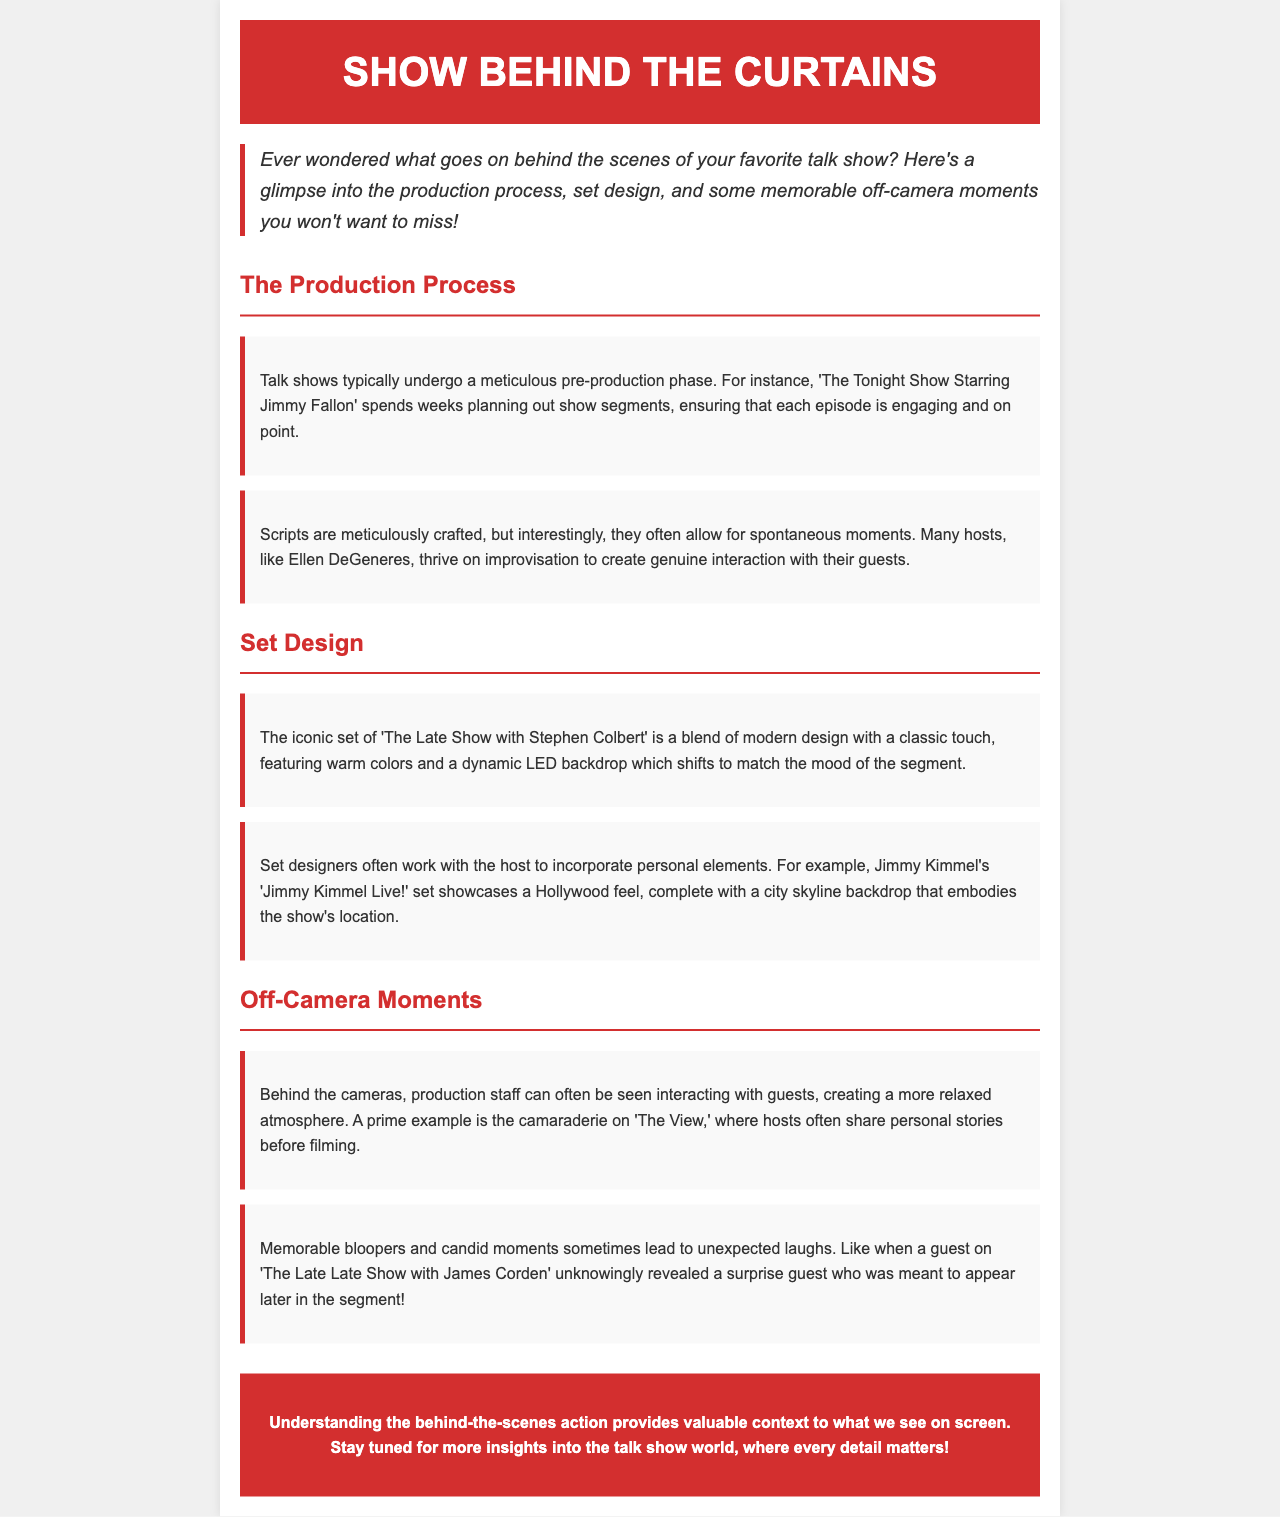What show spends weeks planning segments? The document mentions that 'The Tonight Show Starring Jimmy Fallon' spends weeks planning out show segments.
Answer: The Tonight Show Starring Jimmy Fallon What is noted as a key feature of 'The Late Show with Stephen Colbert's set? The set is described as having a dynamic LED backdrop that shifts to match the mood of the segment.
Answer: Dynamic LED backdrop Which talk show is highlighted for allowing for improvisation by the host? The document notes that many hosts, like Ellen DeGeneres, thrive on improvisation.
Answer: Ellen DeGeneres What atmosphere do production staff create off-camera on 'The View'? The document states that production staff interact with guests, creating a more relaxed atmosphere.
Answer: Relaxed atmosphere What type of moments can lead to unexpected laughs on 'The Late Late Show with James Corden'? Memorable bloopers and candid moments are mentioned as leading to unexpected laughs.
Answer: Memorable bloopers What design elements are included in Jimmy Kimmel's set? The document highlights that the set has a Hollywood feel with a city skyline backdrop.
Answer: Hollywood feel How is the introduction formatted in the newsletter? The introduction is italicized and has a border left with color.
Answer: Italicized with border What color is the background of the conclusion section? The document specifies that the conclusion section has a background color of #d32f2f (red).
Answer: #d32f2f 